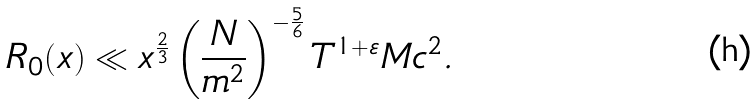Convert formula to latex. <formula><loc_0><loc_0><loc_500><loc_500>R _ { 0 } ( x ) \ll x ^ { \frac { 2 } { 3 } } \left ( \frac { N } { m ^ { 2 } } \right ) ^ { - \frac { 5 } { 6 } } T ^ { 1 + \varepsilon } M c ^ { 2 } .</formula> 